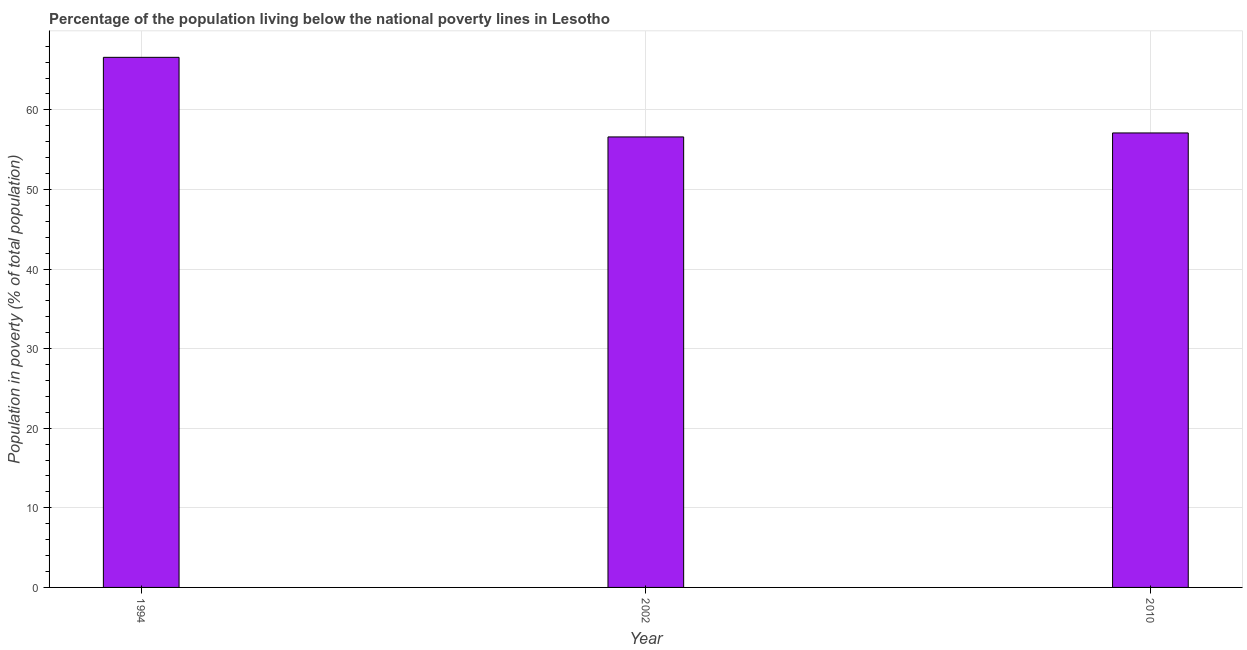What is the title of the graph?
Make the answer very short. Percentage of the population living below the national poverty lines in Lesotho. What is the label or title of the X-axis?
Offer a very short reply. Year. What is the label or title of the Y-axis?
Your response must be concise. Population in poverty (% of total population). What is the percentage of population living below poverty line in 2010?
Offer a terse response. 57.1. Across all years, what is the maximum percentage of population living below poverty line?
Your response must be concise. 66.6. Across all years, what is the minimum percentage of population living below poverty line?
Give a very brief answer. 56.6. What is the sum of the percentage of population living below poverty line?
Offer a very short reply. 180.3. What is the difference between the percentage of population living below poverty line in 1994 and 2010?
Keep it short and to the point. 9.5. What is the average percentage of population living below poverty line per year?
Provide a succinct answer. 60.1. What is the median percentage of population living below poverty line?
Offer a terse response. 57.1. What is the ratio of the percentage of population living below poverty line in 1994 to that in 2010?
Offer a very short reply. 1.17. Is the percentage of population living below poverty line in 1994 less than that in 2002?
Your response must be concise. No. Is the difference between the percentage of population living below poverty line in 1994 and 2002 greater than the difference between any two years?
Your answer should be very brief. Yes. What is the difference between the highest and the second highest percentage of population living below poverty line?
Provide a short and direct response. 9.5. What is the difference between the highest and the lowest percentage of population living below poverty line?
Offer a very short reply. 10. In how many years, is the percentage of population living below poverty line greater than the average percentage of population living below poverty line taken over all years?
Give a very brief answer. 1. How many bars are there?
Ensure brevity in your answer.  3. Are all the bars in the graph horizontal?
Give a very brief answer. No. What is the difference between two consecutive major ticks on the Y-axis?
Provide a succinct answer. 10. Are the values on the major ticks of Y-axis written in scientific E-notation?
Your answer should be compact. No. What is the Population in poverty (% of total population) in 1994?
Give a very brief answer. 66.6. What is the Population in poverty (% of total population) in 2002?
Offer a terse response. 56.6. What is the Population in poverty (% of total population) of 2010?
Offer a very short reply. 57.1. What is the difference between the Population in poverty (% of total population) in 2002 and 2010?
Your response must be concise. -0.5. What is the ratio of the Population in poverty (% of total population) in 1994 to that in 2002?
Provide a short and direct response. 1.18. What is the ratio of the Population in poverty (% of total population) in 1994 to that in 2010?
Keep it short and to the point. 1.17. What is the ratio of the Population in poverty (% of total population) in 2002 to that in 2010?
Your answer should be compact. 0.99. 